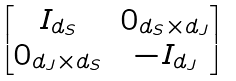Convert formula to latex. <formula><loc_0><loc_0><loc_500><loc_500>\begin{bmatrix} I _ { d _ { S } } & 0 _ { d _ { S } \times d _ { J } } \\ 0 _ { d _ { J } \times d _ { S } } & - I _ { d _ { J } } \end{bmatrix}</formula> 